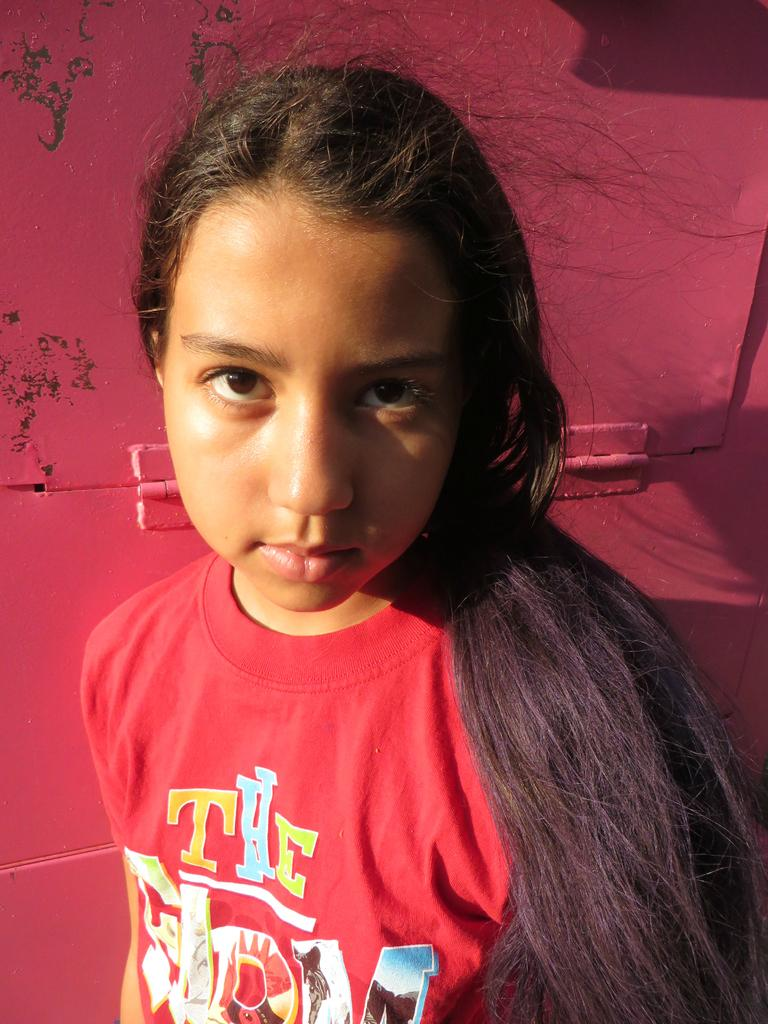<image>
Present a compact description of the photo's key features. A young girl wears a brightly colored shirt that says THE and another word on it. 